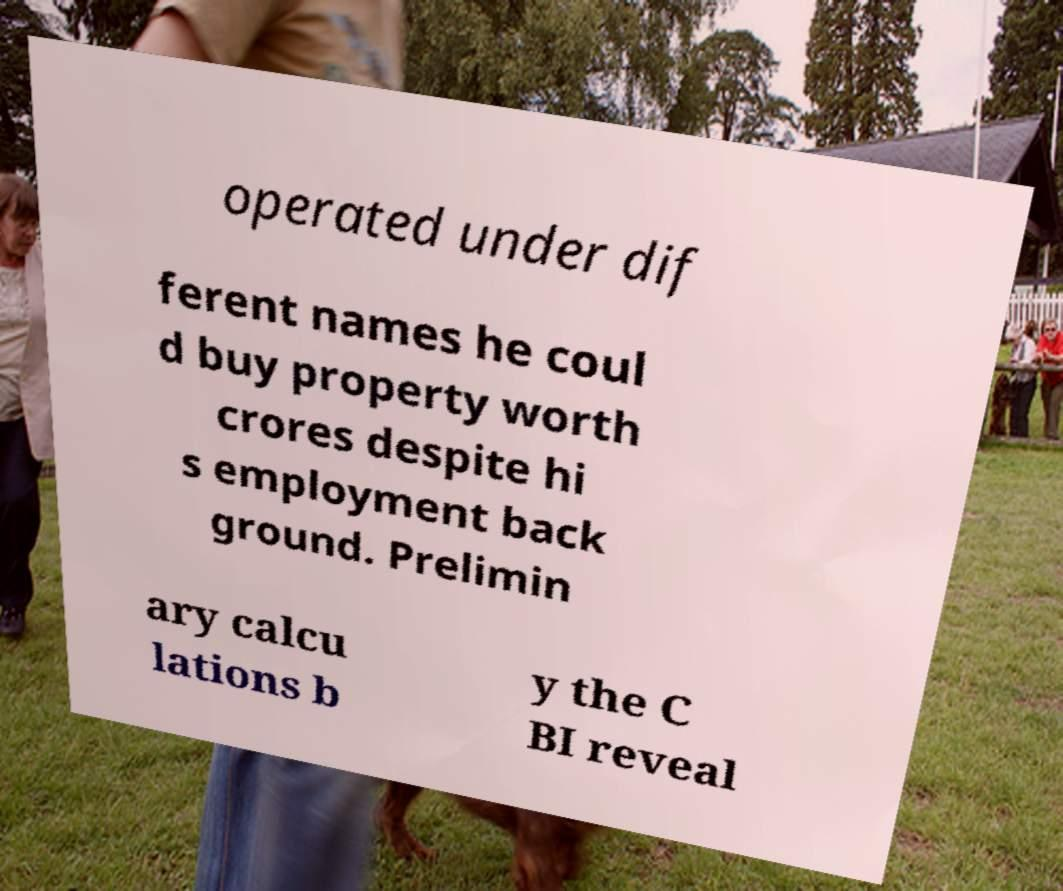Can you read and provide the text displayed in the image?This photo seems to have some interesting text. Can you extract and type it out for me? operated under dif ferent names he coul d buy property worth crores despite hi s employment back ground. Prelimin ary calcu lations b y the C BI reveal 